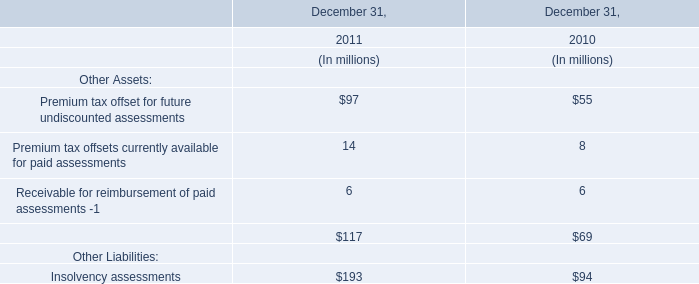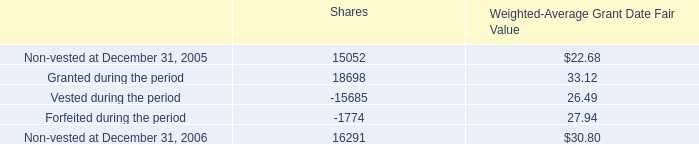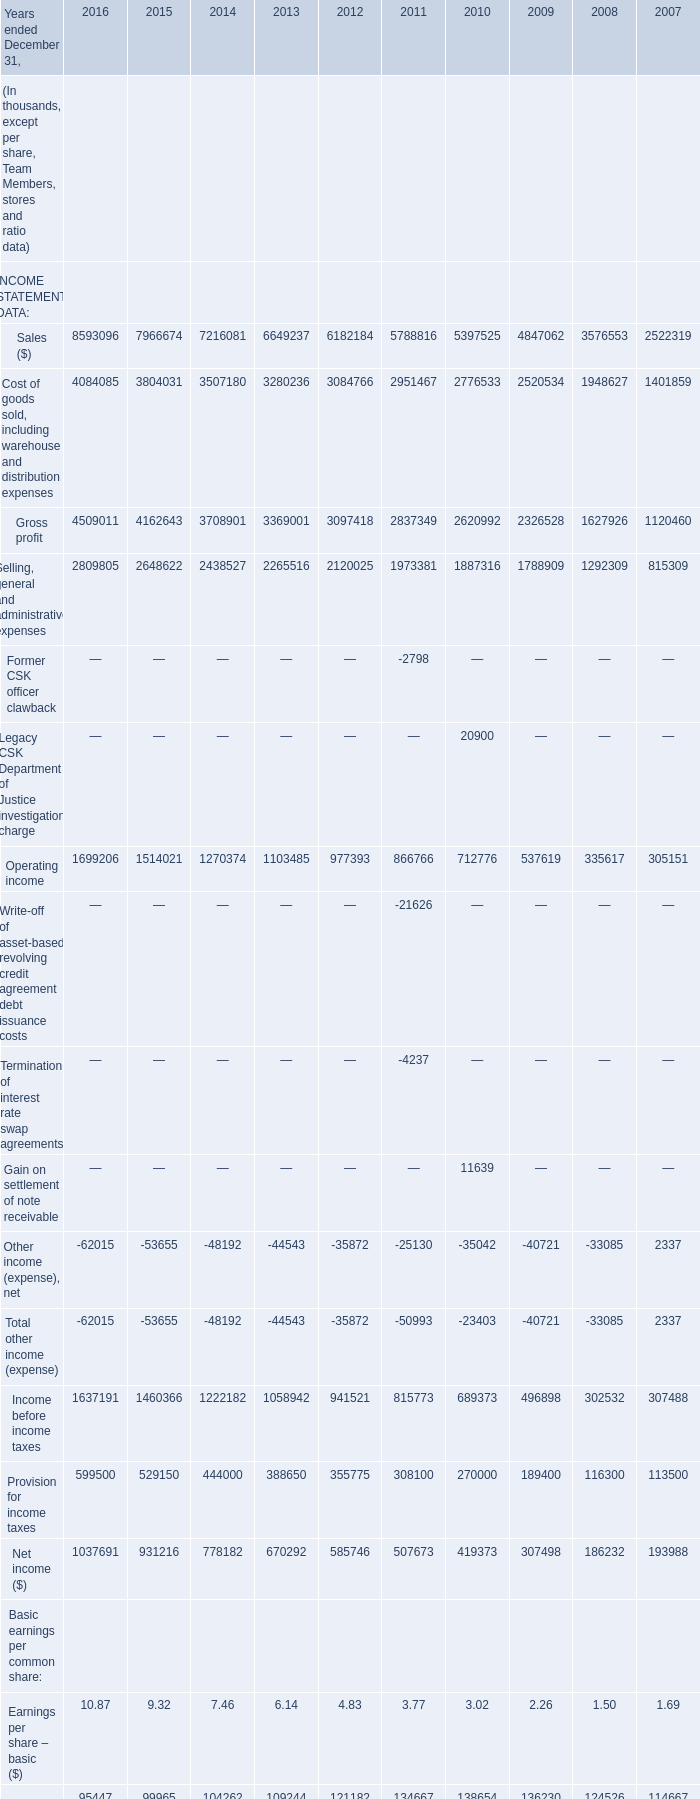In the year with the most Sales, what is the growth rate of Gross profit? (in million) 
Computations: ((4509011 - 4162643) / 4162643)
Answer: 0.08321. 